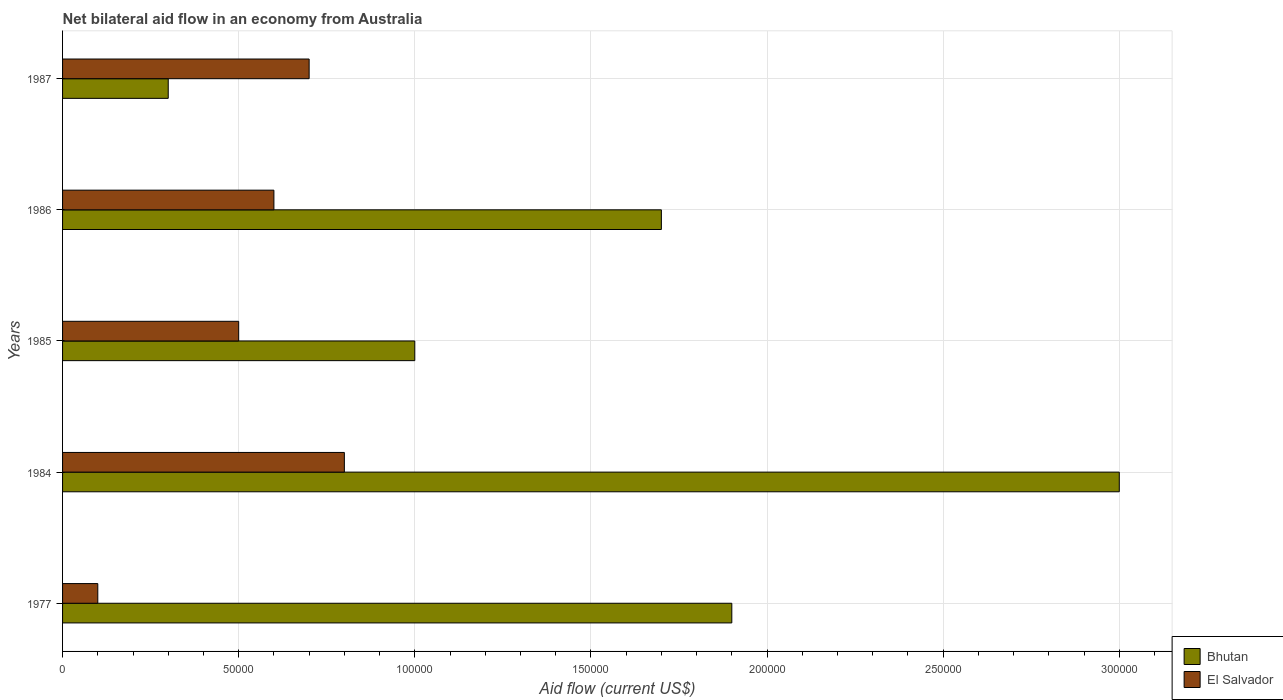How many groups of bars are there?
Keep it short and to the point. 5. Are the number of bars on each tick of the Y-axis equal?
Your answer should be very brief. Yes. How many bars are there on the 5th tick from the bottom?
Offer a very short reply. 2. In how many cases, is the number of bars for a given year not equal to the number of legend labels?
Make the answer very short. 0. What is the net bilateral aid flow in Bhutan in 1977?
Your answer should be compact. 1.90e+05. Across all years, what is the minimum net bilateral aid flow in Bhutan?
Your answer should be very brief. 3.00e+04. In which year was the net bilateral aid flow in Bhutan maximum?
Provide a short and direct response. 1984. In which year was the net bilateral aid flow in Bhutan minimum?
Offer a terse response. 1987. What is the total net bilateral aid flow in Bhutan in the graph?
Make the answer very short. 7.90e+05. What is the difference between the net bilateral aid flow in Bhutan in 1977 and that in 1984?
Offer a very short reply. -1.10e+05. What is the difference between the net bilateral aid flow in Bhutan in 1987 and the net bilateral aid flow in El Salvador in 1985?
Your answer should be very brief. -2.00e+04. What is the average net bilateral aid flow in El Salvador per year?
Provide a short and direct response. 5.40e+04. In the year 1985, what is the difference between the net bilateral aid flow in Bhutan and net bilateral aid flow in El Salvador?
Keep it short and to the point. 5.00e+04. Is the difference between the net bilateral aid flow in Bhutan in 1984 and 1985 greater than the difference between the net bilateral aid flow in El Salvador in 1984 and 1985?
Offer a terse response. Yes. What is the difference between the highest and the lowest net bilateral aid flow in El Salvador?
Your answer should be compact. 7.00e+04. In how many years, is the net bilateral aid flow in Bhutan greater than the average net bilateral aid flow in Bhutan taken over all years?
Your answer should be compact. 3. What does the 1st bar from the top in 1985 represents?
Keep it short and to the point. El Salvador. What does the 1st bar from the bottom in 1977 represents?
Offer a terse response. Bhutan. How many years are there in the graph?
Make the answer very short. 5. What is the difference between two consecutive major ticks on the X-axis?
Offer a very short reply. 5.00e+04. Are the values on the major ticks of X-axis written in scientific E-notation?
Your response must be concise. No. Where does the legend appear in the graph?
Offer a terse response. Bottom right. How many legend labels are there?
Offer a very short reply. 2. How are the legend labels stacked?
Your answer should be compact. Vertical. What is the title of the graph?
Offer a terse response. Net bilateral aid flow in an economy from Australia. What is the label or title of the X-axis?
Keep it short and to the point. Aid flow (current US$). What is the label or title of the Y-axis?
Provide a succinct answer. Years. What is the Aid flow (current US$) in Bhutan in 1977?
Offer a terse response. 1.90e+05. What is the Aid flow (current US$) in El Salvador in 1977?
Keep it short and to the point. 10000. What is the Aid flow (current US$) in El Salvador in 1987?
Your response must be concise. 7.00e+04. Across all years, what is the maximum Aid flow (current US$) of Bhutan?
Your answer should be very brief. 3.00e+05. What is the total Aid flow (current US$) of Bhutan in the graph?
Offer a very short reply. 7.90e+05. What is the total Aid flow (current US$) of El Salvador in the graph?
Ensure brevity in your answer.  2.70e+05. What is the difference between the Aid flow (current US$) in El Salvador in 1977 and that in 1984?
Provide a succinct answer. -7.00e+04. What is the difference between the Aid flow (current US$) in Bhutan in 1977 and that in 1985?
Ensure brevity in your answer.  9.00e+04. What is the difference between the Aid flow (current US$) in El Salvador in 1977 and that in 1985?
Keep it short and to the point. -4.00e+04. What is the difference between the Aid flow (current US$) of Bhutan in 1977 and that in 1987?
Offer a very short reply. 1.60e+05. What is the difference between the Aid flow (current US$) of El Salvador in 1977 and that in 1987?
Your answer should be very brief. -6.00e+04. What is the difference between the Aid flow (current US$) of Bhutan in 1984 and that in 1985?
Give a very brief answer. 2.00e+05. What is the difference between the Aid flow (current US$) of El Salvador in 1984 and that in 1985?
Make the answer very short. 3.00e+04. What is the difference between the Aid flow (current US$) in El Salvador in 1984 and that in 1987?
Provide a succinct answer. 10000. What is the difference between the Aid flow (current US$) of Bhutan in 1985 and that in 1986?
Your answer should be compact. -7.00e+04. What is the difference between the Aid flow (current US$) of El Salvador in 1985 and that in 1986?
Offer a very short reply. -10000. What is the difference between the Aid flow (current US$) in Bhutan in 1985 and that in 1987?
Ensure brevity in your answer.  7.00e+04. What is the difference between the Aid flow (current US$) of El Salvador in 1986 and that in 1987?
Ensure brevity in your answer.  -10000. What is the difference between the Aid flow (current US$) in Bhutan in 1977 and the Aid flow (current US$) in El Salvador in 1984?
Provide a succinct answer. 1.10e+05. What is the difference between the Aid flow (current US$) of Bhutan in 1977 and the Aid flow (current US$) of El Salvador in 1985?
Give a very brief answer. 1.40e+05. What is the difference between the Aid flow (current US$) in Bhutan in 1977 and the Aid flow (current US$) in El Salvador in 1986?
Offer a very short reply. 1.30e+05. What is the difference between the Aid flow (current US$) of Bhutan in 1977 and the Aid flow (current US$) of El Salvador in 1987?
Make the answer very short. 1.20e+05. What is the difference between the Aid flow (current US$) in Bhutan in 1984 and the Aid flow (current US$) in El Salvador in 1987?
Make the answer very short. 2.30e+05. What is the difference between the Aid flow (current US$) in Bhutan in 1985 and the Aid flow (current US$) in El Salvador in 1986?
Give a very brief answer. 4.00e+04. What is the average Aid flow (current US$) in Bhutan per year?
Provide a succinct answer. 1.58e+05. What is the average Aid flow (current US$) of El Salvador per year?
Your answer should be very brief. 5.40e+04. In the year 1984, what is the difference between the Aid flow (current US$) of Bhutan and Aid flow (current US$) of El Salvador?
Make the answer very short. 2.20e+05. In the year 1987, what is the difference between the Aid flow (current US$) in Bhutan and Aid flow (current US$) in El Salvador?
Provide a short and direct response. -4.00e+04. What is the ratio of the Aid flow (current US$) of Bhutan in 1977 to that in 1984?
Keep it short and to the point. 0.63. What is the ratio of the Aid flow (current US$) of Bhutan in 1977 to that in 1986?
Offer a terse response. 1.12. What is the ratio of the Aid flow (current US$) in El Salvador in 1977 to that in 1986?
Ensure brevity in your answer.  0.17. What is the ratio of the Aid flow (current US$) of Bhutan in 1977 to that in 1987?
Offer a terse response. 6.33. What is the ratio of the Aid flow (current US$) of El Salvador in 1977 to that in 1987?
Offer a very short reply. 0.14. What is the ratio of the Aid flow (current US$) in Bhutan in 1984 to that in 1986?
Offer a terse response. 1.76. What is the ratio of the Aid flow (current US$) in El Salvador in 1984 to that in 1986?
Give a very brief answer. 1.33. What is the ratio of the Aid flow (current US$) in Bhutan in 1984 to that in 1987?
Provide a succinct answer. 10. What is the ratio of the Aid flow (current US$) in El Salvador in 1984 to that in 1987?
Your answer should be very brief. 1.14. What is the ratio of the Aid flow (current US$) in Bhutan in 1985 to that in 1986?
Offer a terse response. 0.59. What is the ratio of the Aid flow (current US$) of El Salvador in 1985 to that in 1986?
Your answer should be very brief. 0.83. What is the ratio of the Aid flow (current US$) of Bhutan in 1986 to that in 1987?
Your response must be concise. 5.67. 